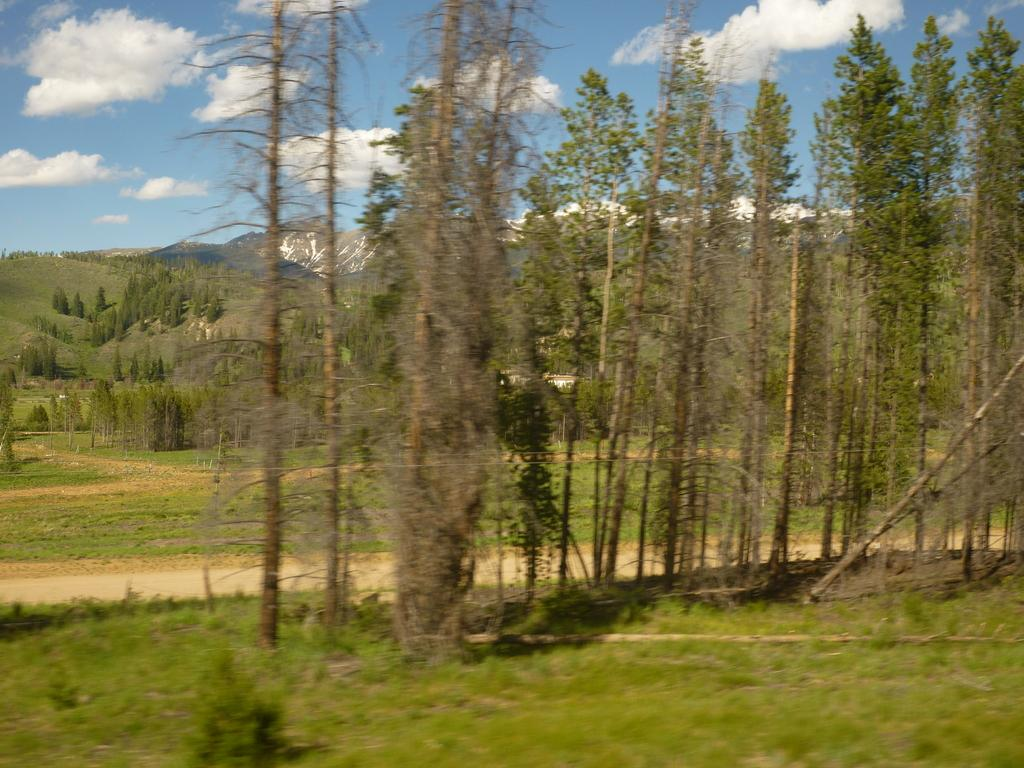What type of terrain is visible in the image? There is grassy land in the image. What other natural elements can be seen in the image? There are trees in the image. What can be seen in the distance in the image? There are mountains in the background of the image. What is visible at the top of the image? The sky is visible at the top of the image. What is the condition of the sky in the image? Clouds are present in the sky. How does the wealth of the visitor affect the image? There is no mention of a visitor or wealth in the image, so it cannot be determined how they might affect the image. 